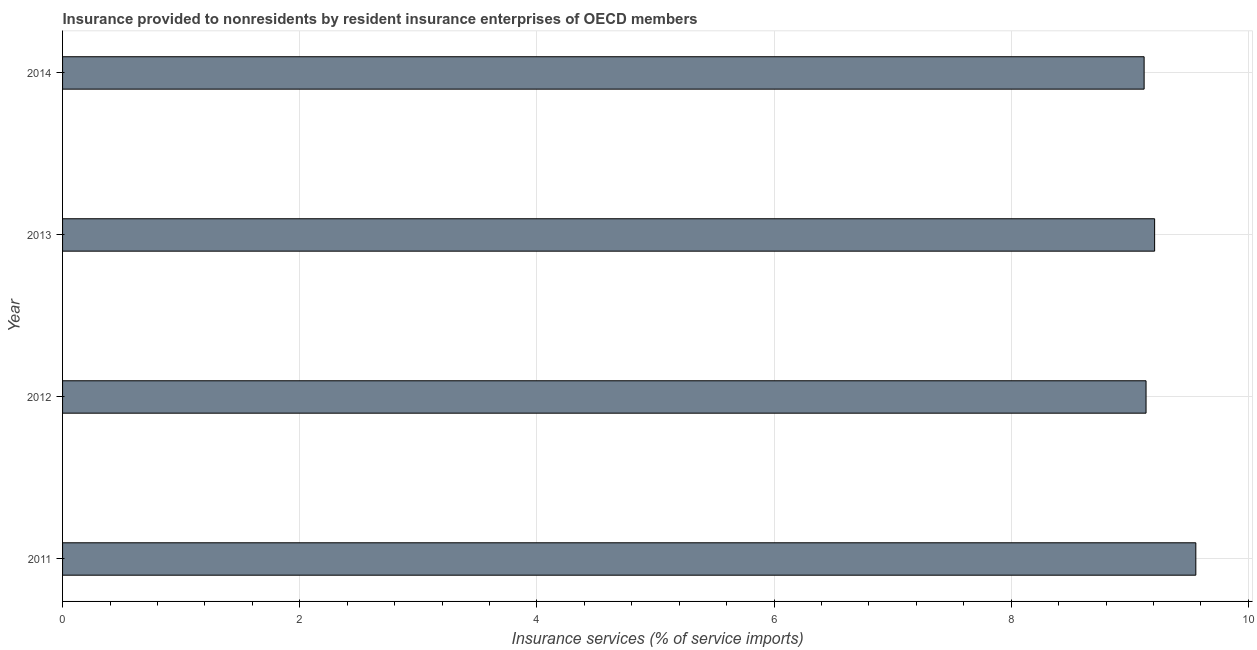Does the graph contain any zero values?
Offer a terse response. No. Does the graph contain grids?
Provide a short and direct response. Yes. What is the title of the graph?
Provide a short and direct response. Insurance provided to nonresidents by resident insurance enterprises of OECD members. What is the label or title of the X-axis?
Your response must be concise. Insurance services (% of service imports). What is the insurance and financial services in 2014?
Give a very brief answer. 9.12. Across all years, what is the maximum insurance and financial services?
Provide a short and direct response. 9.56. Across all years, what is the minimum insurance and financial services?
Keep it short and to the point. 9.12. What is the sum of the insurance and financial services?
Provide a succinct answer. 37.03. What is the difference between the insurance and financial services in 2011 and 2012?
Give a very brief answer. 0.42. What is the average insurance and financial services per year?
Keep it short and to the point. 9.26. What is the median insurance and financial services?
Provide a short and direct response. 9.17. What is the difference between the highest and the second highest insurance and financial services?
Make the answer very short. 0.35. Is the sum of the insurance and financial services in 2013 and 2014 greater than the maximum insurance and financial services across all years?
Your response must be concise. Yes. What is the difference between the highest and the lowest insurance and financial services?
Offer a terse response. 0.44. In how many years, is the insurance and financial services greater than the average insurance and financial services taken over all years?
Offer a terse response. 1. How many years are there in the graph?
Make the answer very short. 4. Are the values on the major ticks of X-axis written in scientific E-notation?
Make the answer very short. No. What is the Insurance services (% of service imports) of 2011?
Provide a short and direct response. 9.56. What is the Insurance services (% of service imports) of 2012?
Give a very brief answer. 9.14. What is the Insurance services (% of service imports) of 2013?
Your response must be concise. 9.21. What is the Insurance services (% of service imports) of 2014?
Your response must be concise. 9.12. What is the difference between the Insurance services (% of service imports) in 2011 and 2012?
Your response must be concise. 0.42. What is the difference between the Insurance services (% of service imports) in 2011 and 2013?
Provide a short and direct response. 0.35. What is the difference between the Insurance services (% of service imports) in 2011 and 2014?
Ensure brevity in your answer.  0.44. What is the difference between the Insurance services (% of service imports) in 2012 and 2013?
Offer a very short reply. -0.07. What is the difference between the Insurance services (% of service imports) in 2012 and 2014?
Provide a short and direct response. 0.02. What is the difference between the Insurance services (% of service imports) in 2013 and 2014?
Offer a very short reply. 0.09. What is the ratio of the Insurance services (% of service imports) in 2011 to that in 2012?
Offer a terse response. 1.05. What is the ratio of the Insurance services (% of service imports) in 2011 to that in 2013?
Ensure brevity in your answer.  1.04. What is the ratio of the Insurance services (% of service imports) in 2011 to that in 2014?
Provide a succinct answer. 1.05. What is the ratio of the Insurance services (% of service imports) in 2012 to that in 2014?
Ensure brevity in your answer.  1. What is the ratio of the Insurance services (% of service imports) in 2013 to that in 2014?
Offer a very short reply. 1.01. 